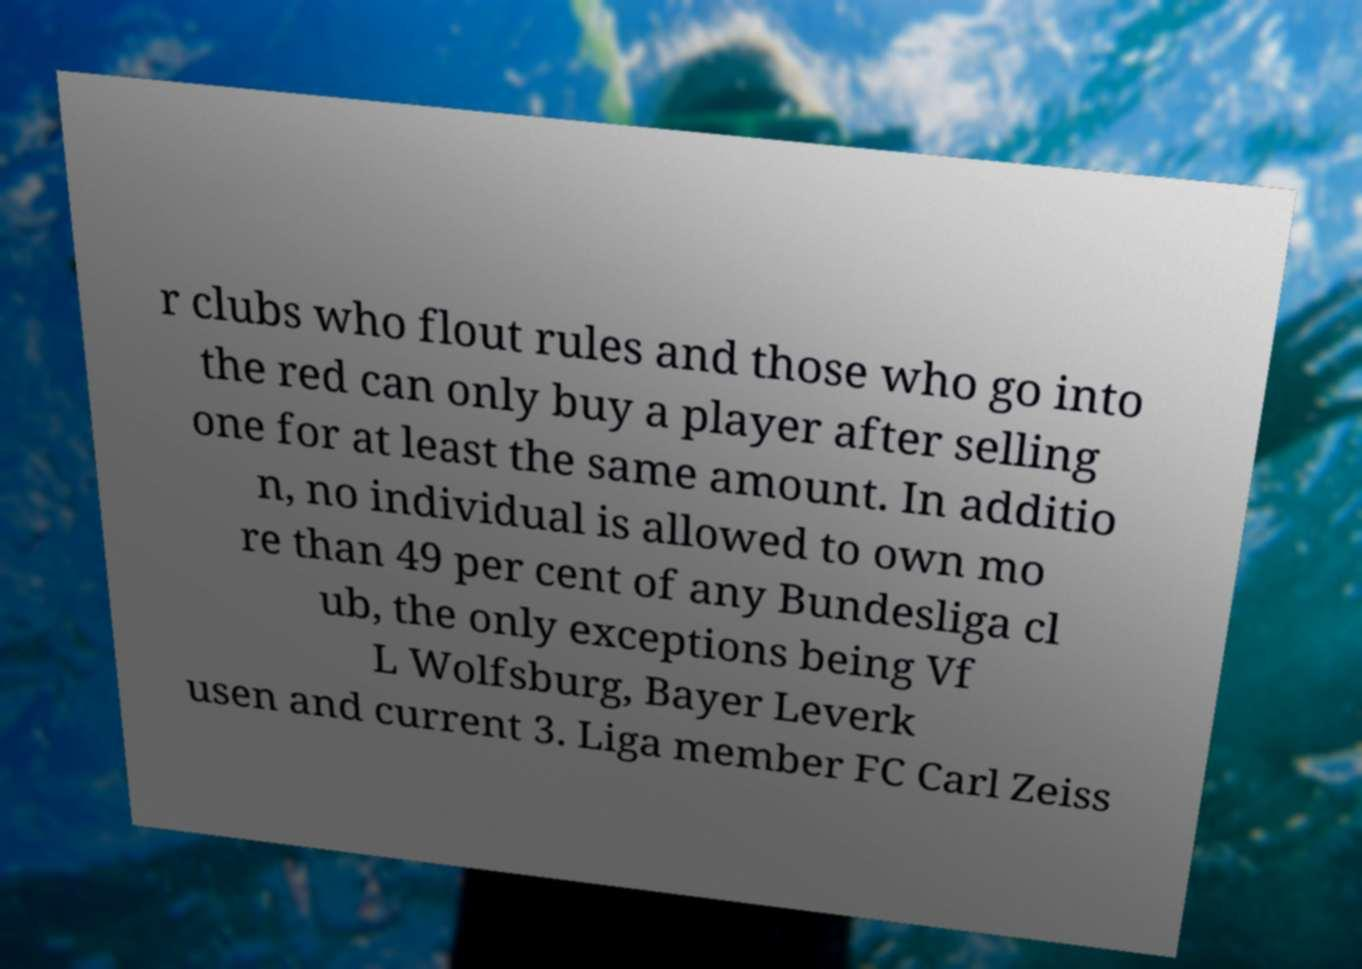What messages or text are displayed in this image? I need them in a readable, typed format. r clubs who flout rules and those who go into the red can only buy a player after selling one for at least the same amount. In additio n, no individual is allowed to own mo re than 49 per cent of any Bundesliga cl ub, the only exceptions being Vf L Wolfsburg, Bayer Leverk usen and current 3. Liga member FC Carl Zeiss 